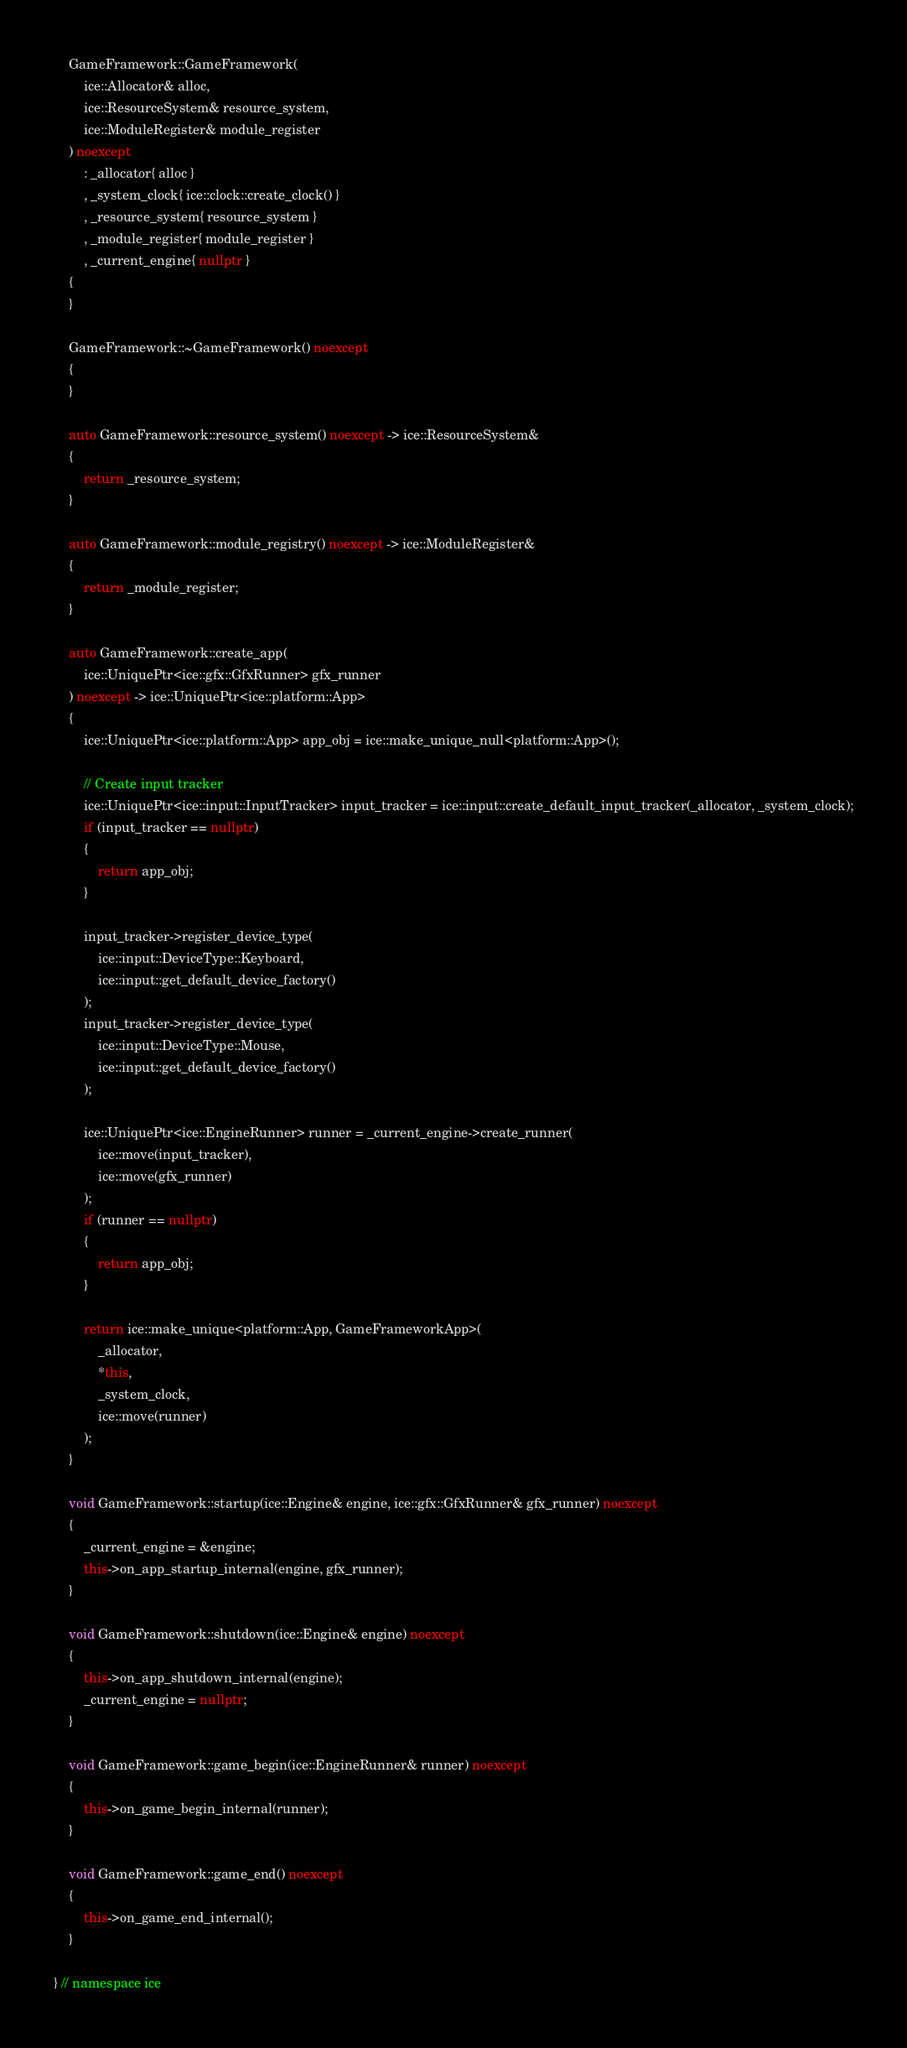Convert code to text. <code><loc_0><loc_0><loc_500><loc_500><_C++_>
    GameFramework::GameFramework(
        ice::Allocator& alloc,
        ice::ResourceSystem& resource_system,
        ice::ModuleRegister& module_register
    ) noexcept
        : _allocator{ alloc }
        , _system_clock{ ice::clock::create_clock() }
        , _resource_system{ resource_system }
        , _module_register{ module_register }
        , _current_engine{ nullptr }
    {
    }

    GameFramework::~GameFramework() noexcept
    {
    }

    auto GameFramework::resource_system() noexcept -> ice::ResourceSystem&
    {
        return _resource_system;
    }

    auto GameFramework::module_registry() noexcept -> ice::ModuleRegister&
    {
        return _module_register;
    }

    auto GameFramework::create_app(
        ice::UniquePtr<ice::gfx::GfxRunner> gfx_runner
    ) noexcept -> ice::UniquePtr<ice::platform::App>
    {
        ice::UniquePtr<ice::platform::App> app_obj = ice::make_unique_null<platform::App>();

        // Create input tracker
        ice::UniquePtr<ice::input::InputTracker> input_tracker = ice::input::create_default_input_tracker(_allocator, _system_clock);
        if (input_tracker == nullptr)
        {
            return app_obj;
        }

        input_tracker->register_device_type(
            ice::input::DeviceType::Keyboard,
            ice::input::get_default_device_factory()
        );
        input_tracker->register_device_type(
            ice::input::DeviceType::Mouse,
            ice::input::get_default_device_factory()
        );

        ice::UniquePtr<ice::EngineRunner> runner = _current_engine->create_runner(
            ice::move(input_tracker),
            ice::move(gfx_runner)
        );
        if (runner == nullptr)
        {
            return app_obj;
        }

        return ice::make_unique<platform::App, GameFrameworkApp>(
            _allocator,
            *this,
            _system_clock,
            ice::move(runner)
        );
    }

    void GameFramework::startup(ice::Engine& engine, ice::gfx::GfxRunner& gfx_runner) noexcept
    {
        _current_engine = &engine;
        this->on_app_startup_internal(engine, gfx_runner);
    }

    void GameFramework::shutdown(ice::Engine& engine) noexcept
    {
        this->on_app_shutdown_internal(engine);
        _current_engine = nullptr;
    }

    void GameFramework::game_begin(ice::EngineRunner& runner) noexcept
    {
        this->on_game_begin_internal(runner);
    }

    void GameFramework::game_end() noexcept
    {
        this->on_game_end_internal();
    }

} // namespace ice</code> 